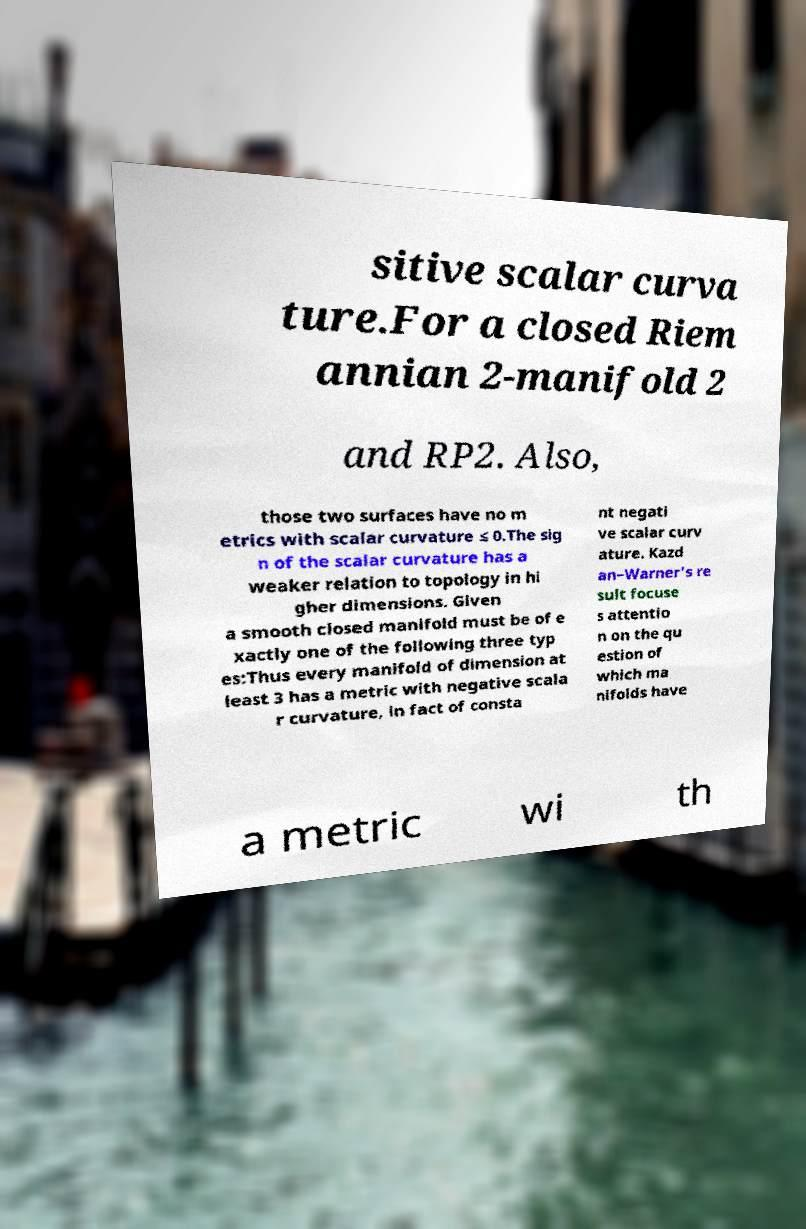Can you accurately transcribe the text from the provided image for me? sitive scalar curva ture.For a closed Riem annian 2-manifold 2 and RP2. Also, those two surfaces have no m etrics with scalar curvature ≤ 0.The sig n of the scalar curvature has a weaker relation to topology in hi gher dimensions. Given a smooth closed manifold must be of e xactly one of the following three typ es:Thus every manifold of dimension at least 3 has a metric with negative scala r curvature, in fact of consta nt negati ve scalar curv ature. Kazd an–Warner's re sult focuse s attentio n on the qu estion of which ma nifolds have a metric wi th 